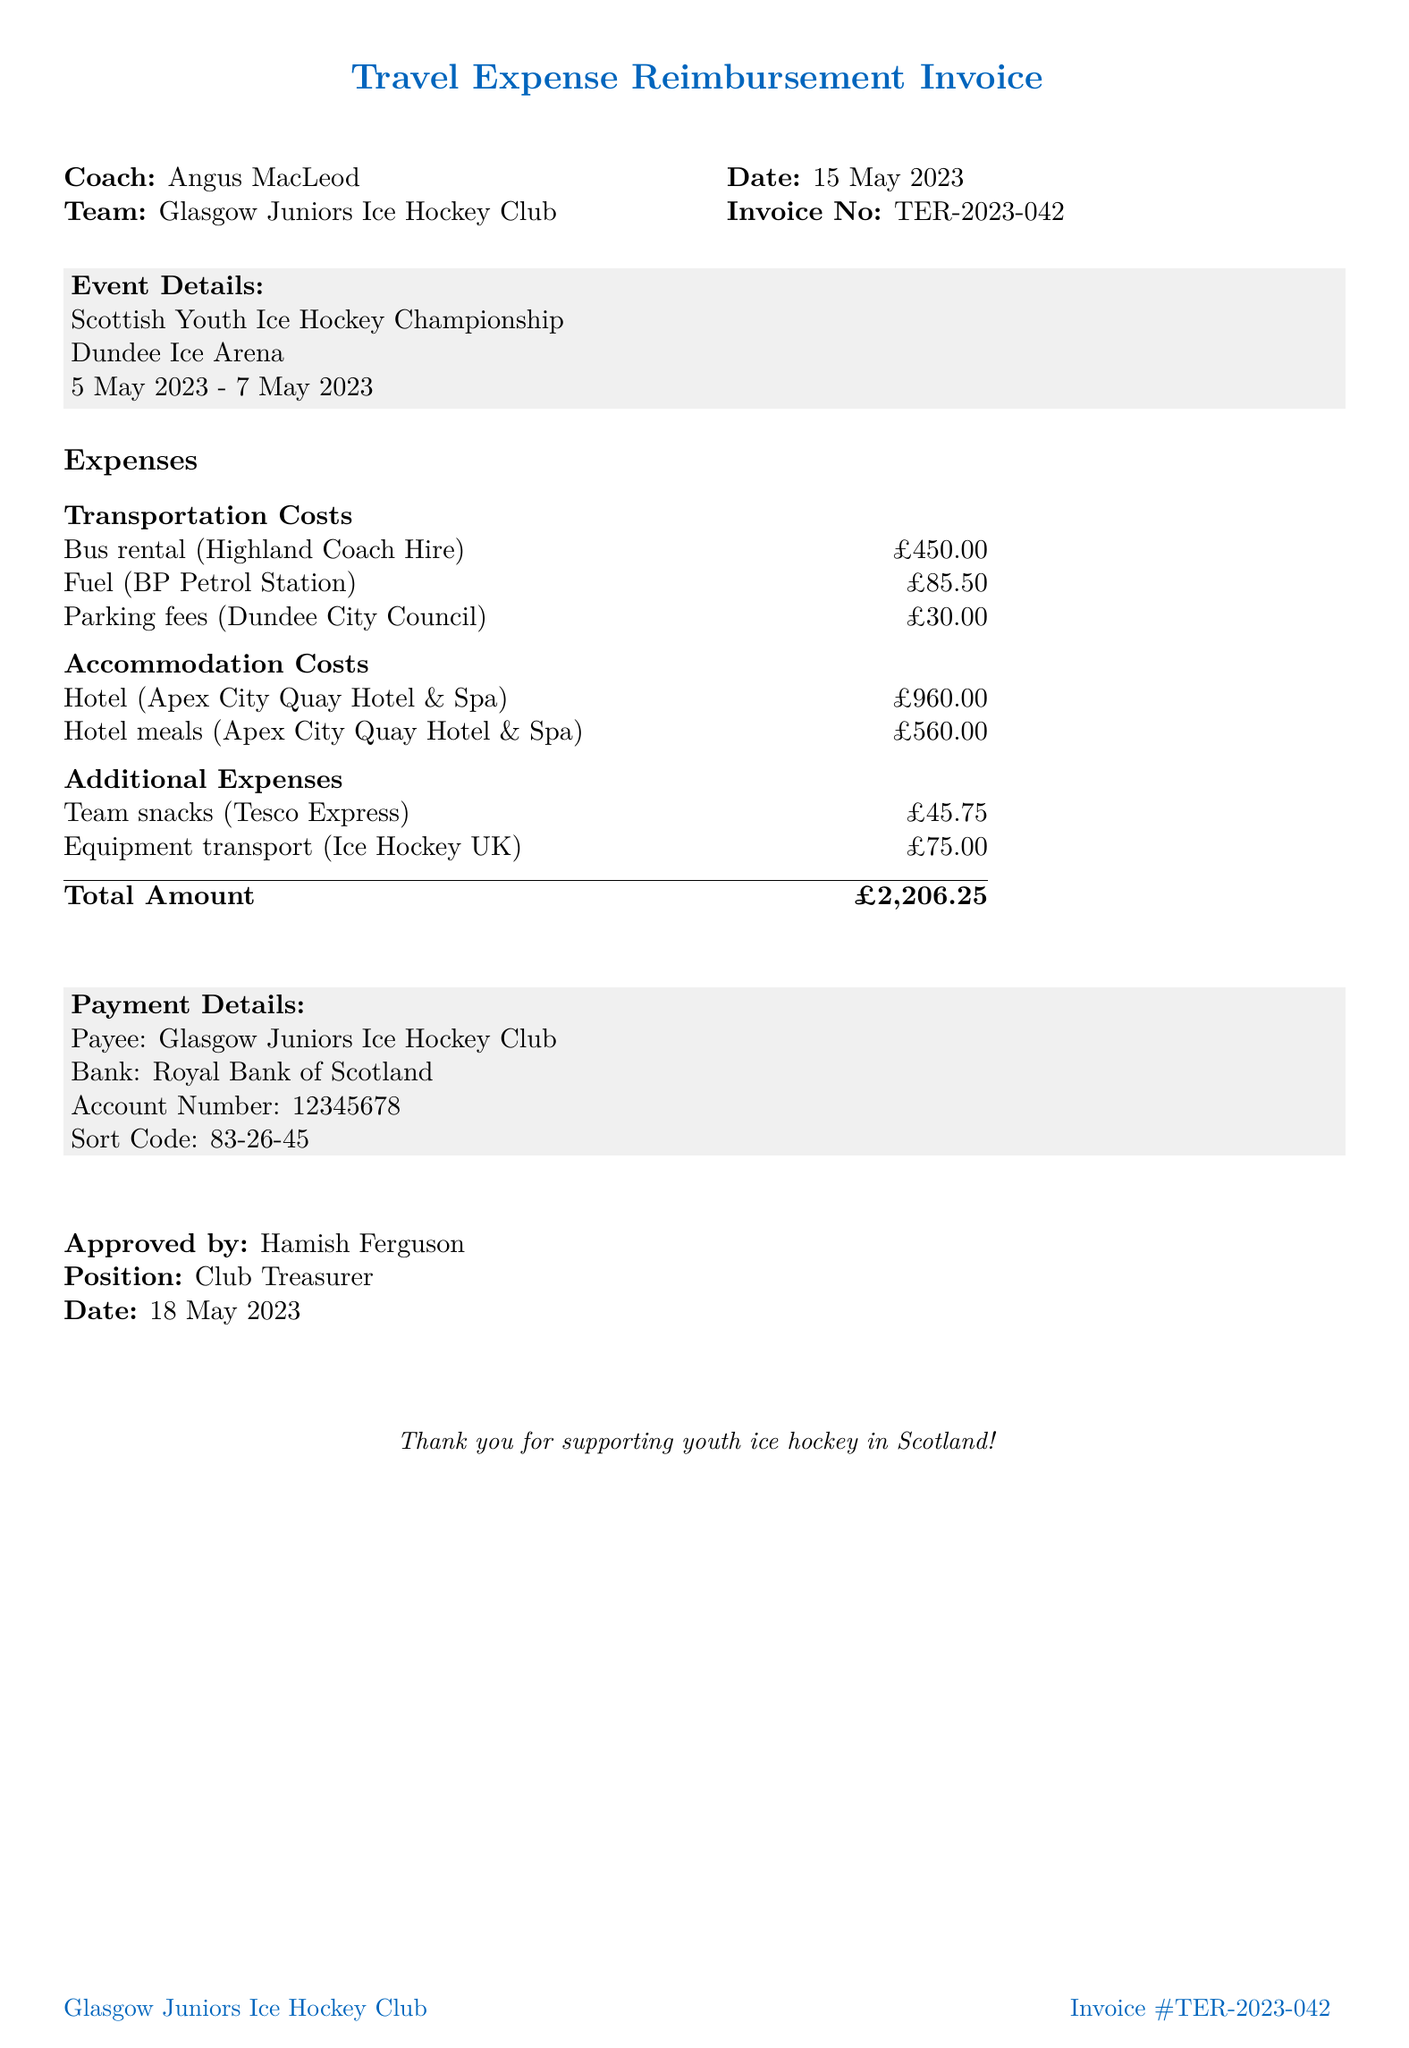What is the invoice number? The invoice number is specified in the document details as a unique identifier for the invoice.
Answer: TER-2023-042 Who is the coach listed on the invoice? The document provides the name of the coach responsible for the expenses incurred during the event.
Answer: Angus MacLeod What is the total amount for the travel expenses? The total amount is calculated by summing all costs associated with transportation, accommodation, and additional expenses listed in the invoice.
Answer: £2206.25 What was the location of the tournament? The document mentions the specific venue where the event took place.
Answer: Dundee Ice Arena How many twin rooms were booked for accommodation? The invoice details specify the number of rooms booked for the team's stay during the tournament.
Answer: 6 What is the provider of the fuel costs? The invoice lists the name of the provider for the fuel expenses incurred during the tournament travel.
Answer: BP Petrol Station What type of expenses were incurred for snacks? The invoice categorizes different types of additional expenses, including those for snacks for the team.
Answer: Team snacks When was the invoice approved? The document states the date when the expenses were reviewed and approved by the designated authority.
Answer: 18 May 2023 